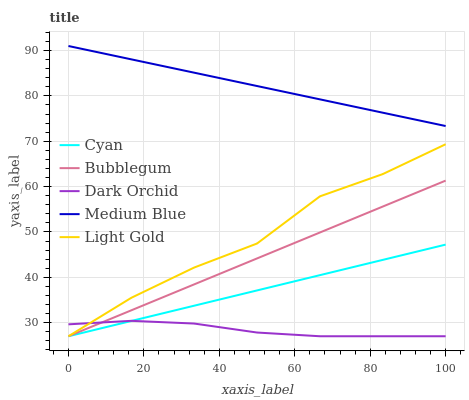Does Dark Orchid have the minimum area under the curve?
Answer yes or no. Yes. Does Medium Blue have the maximum area under the curve?
Answer yes or no. Yes. Does Light Gold have the minimum area under the curve?
Answer yes or no. No. Does Light Gold have the maximum area under the curve?
Answer yes or no. No. Is Cyan the smoothest?
Answer yes or no. Yes. Is Light Gold the roughest?
Answer yes or no. Yes. Is Medium Blue the smoothest?
Answer yes or no. No. Is Medium Blue the roughest?
Answer yes or no. No. Does Medium Blue have the lowest value?
Answer yes or no. No. Does Light Gold have the highest value?
Answer yes or no. No. Is Cyan less than Medium Blue?
Answer yes or no. Yes. Is Medium Blue greater than Dark Orchid?
Answer yes or no. Yes. Does Cyan intersect Medium Blue?
Answer yes or no. No. 